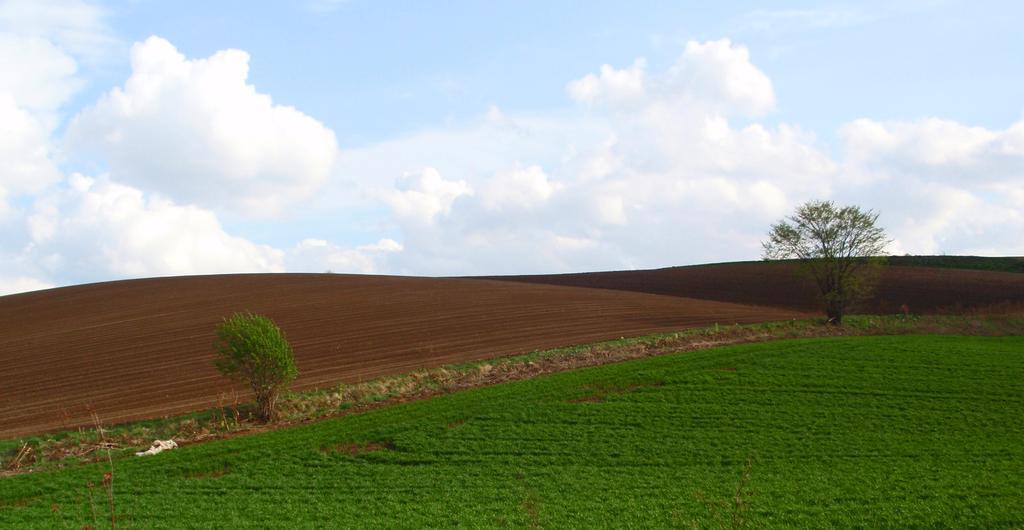How would you summarize this image in a sentence or two? This picture is clicked outside. In the foreground we can see the green grass. In the center we can see the trees and the mud. In the background we can see the sky which is full of clouds. 